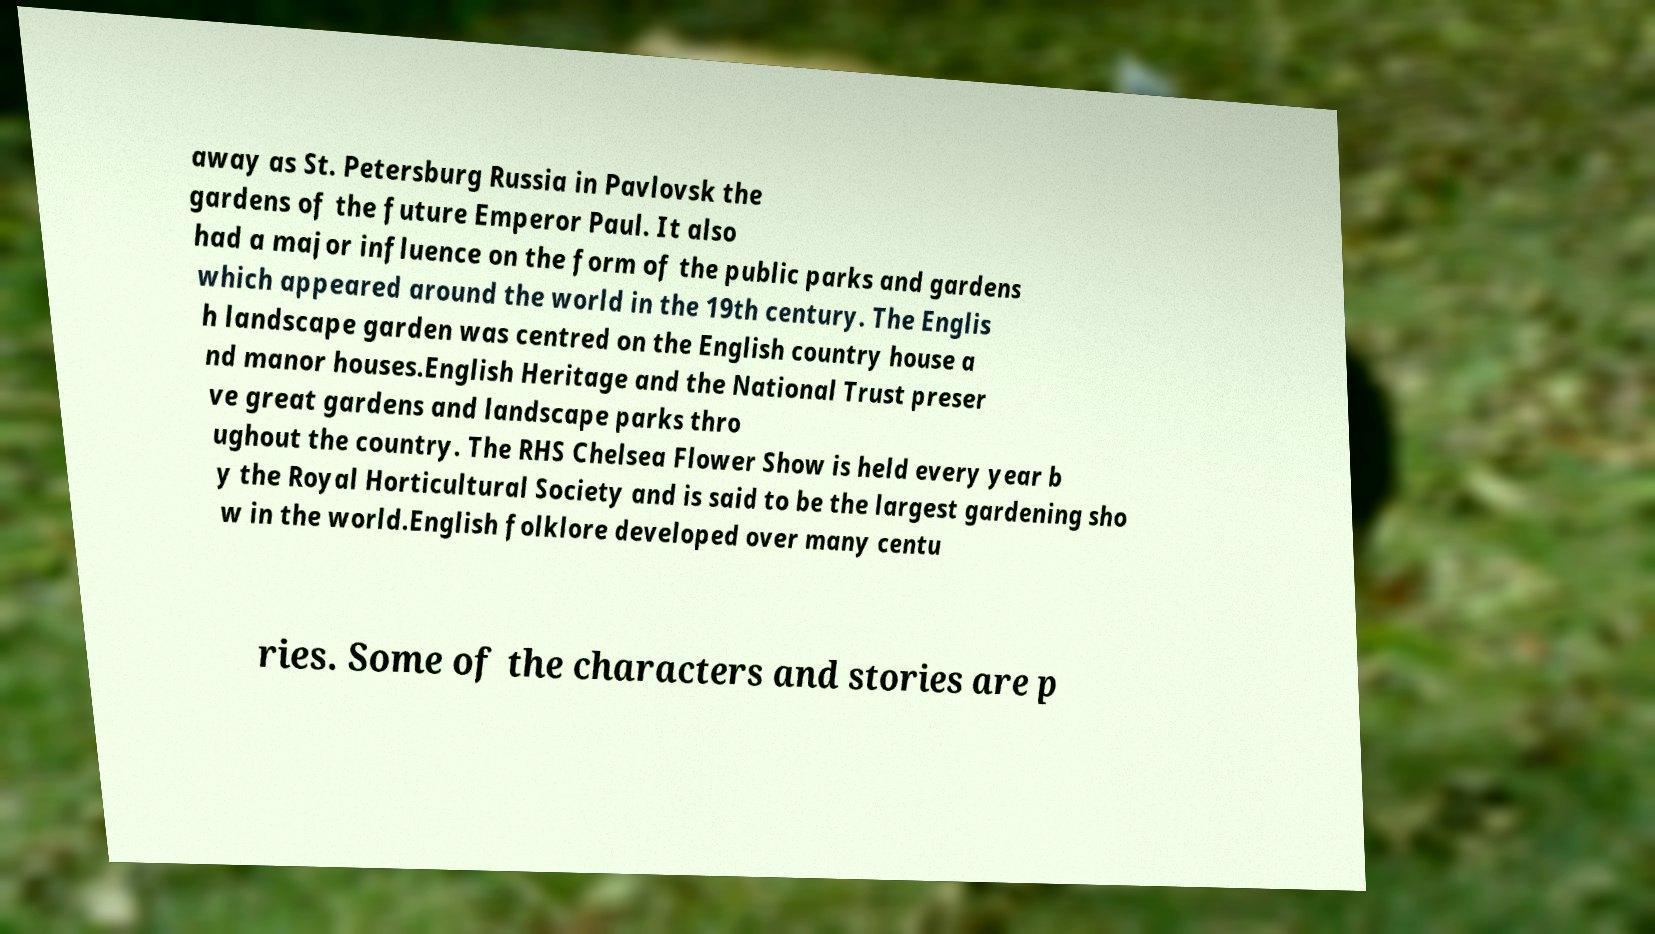Could you assist in decoding the text presented in this image and type it out clearly? away as St. Petersburg Russia in Pavlovsk the gardens of the future Emperor Paul. It also had a major influence on the form of the public parks and gardens which appeared around the world in the 19th century. The Englis h landscape garden was centred on the English country house a nd manor houses.English Heritage and the National Trust preser ve great gardens and landscape parks thro ughout the country. The RHS Chelsea Flower Show is held every year b y the Royal Horticultural Society and is said to be the largest gardening sho w in the world.English folklore developed over many centu ries. Some of the characters and stories are p 